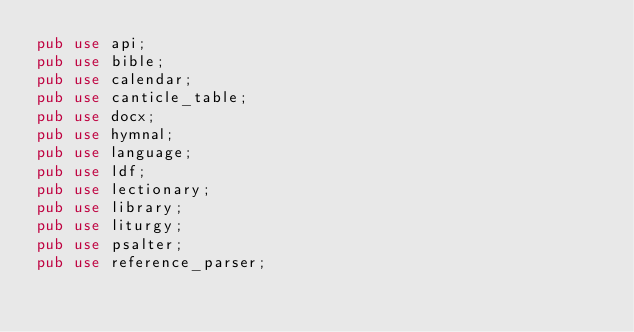<code> <loc_0><loc_0><loc_500><loc_500><_Rust_>pub use api;
pub use bible;
pub use calendar;
pub use canticle_table;
pub use docx;
pub use hymnal;
pub use language;
pub use ldf;
pub use lectionary;
pub use library;
pub use liturgy;
pub use psalter;
pub use reference_parser;
</code> 